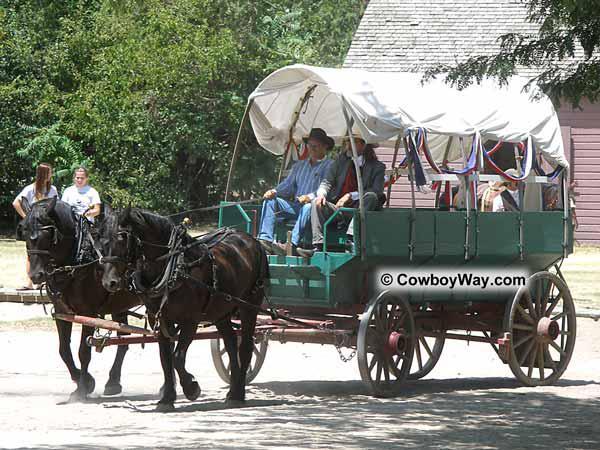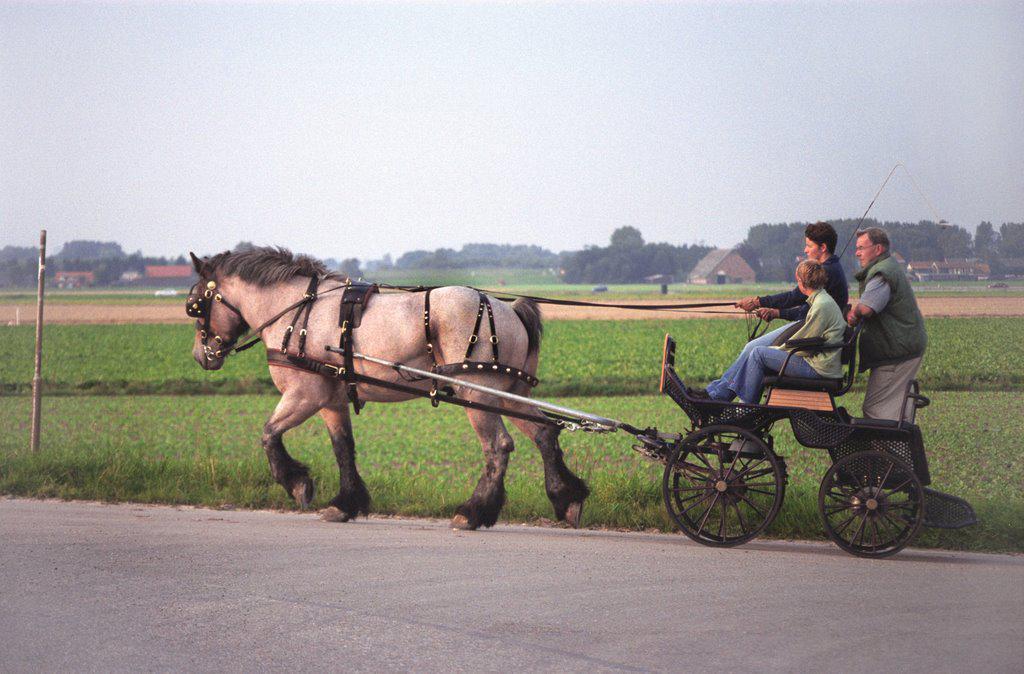The first image is the image on the left, the second image is the image on the right. Considering the images on both sides, is "All images show one full-size horse pulling a cart." valid? Answer yes or no. No. 